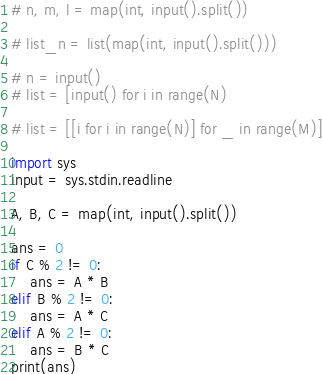<code> <loc_0><loc_0><loc_500><loc_500><_Python_># n, m, l = map(int, input().split())

# list_n = list(map(int, input().split()))

# n = input()
# list = [input() for i in range(N)

# list = [[i for i in range(N)] for _ in range(M)]

import sys
input = sys.stdin.readline

A, B, C = map(int, input().split())

ans = 0
if C % 2 != 0:
    ans = A * B
elif B % 2 != 0:
    ans = A * C
elif A % 2 != 0:
    ans = B * C
print(ans)
</code> 